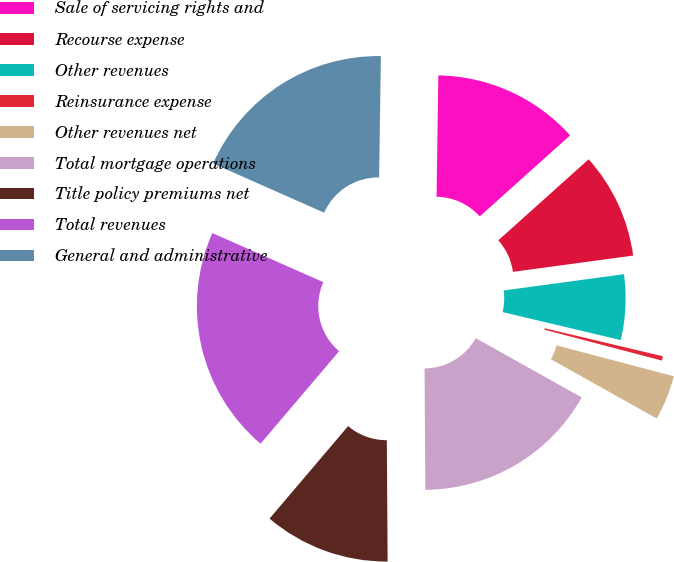Convert chart. <chart><loc_0><loc_0><loc_500><loc_500><pie_chart><fcel>Sale of servicing rights and<fcel>Recourse expense<fcel>Other revenues<fcel>Reinsurance expense<fcel>Other revenues net<fcel>Total mortgage operations<fcel>Title policy premiums net<fcel>Total revenues<fcel>General and administrative<nl><fcel>13.13%<fcel>9.49%<fcel>5.85%<fcel>0.39%<fcel>4.03%<fcel>16.77%<fcel>11.31%<fcel>20.42%<fcel>18.6%<nl></chart> 